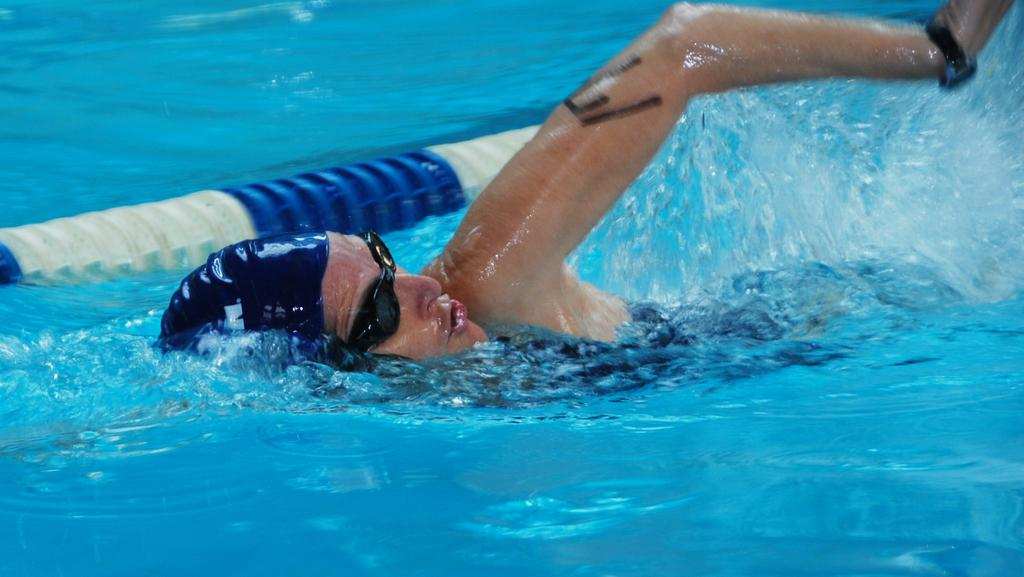What is the person in the image doing? The person is swimming in the image. Where is the person swimming? The person is in water. What can be seen in the image besides the person swimming? There is a barrier in the image. What type of iron can be seen in the image? There is no iron present in the image. What kind of corn is being harvested in the image? There is no corn or harvesting activity in the image. 